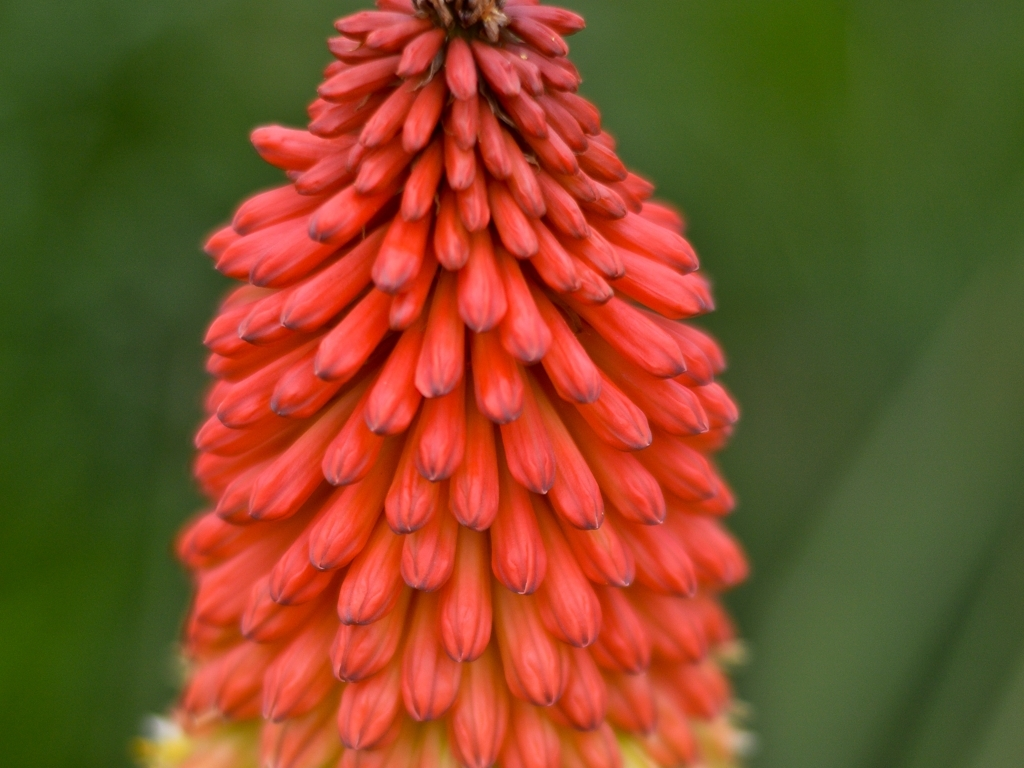What type of flower is shown in this image? The image features a close-up of a Red Hot Poker or Kniphofia, characterized by its striking, torch-like flower spikes with vibrant red to orange petals. 